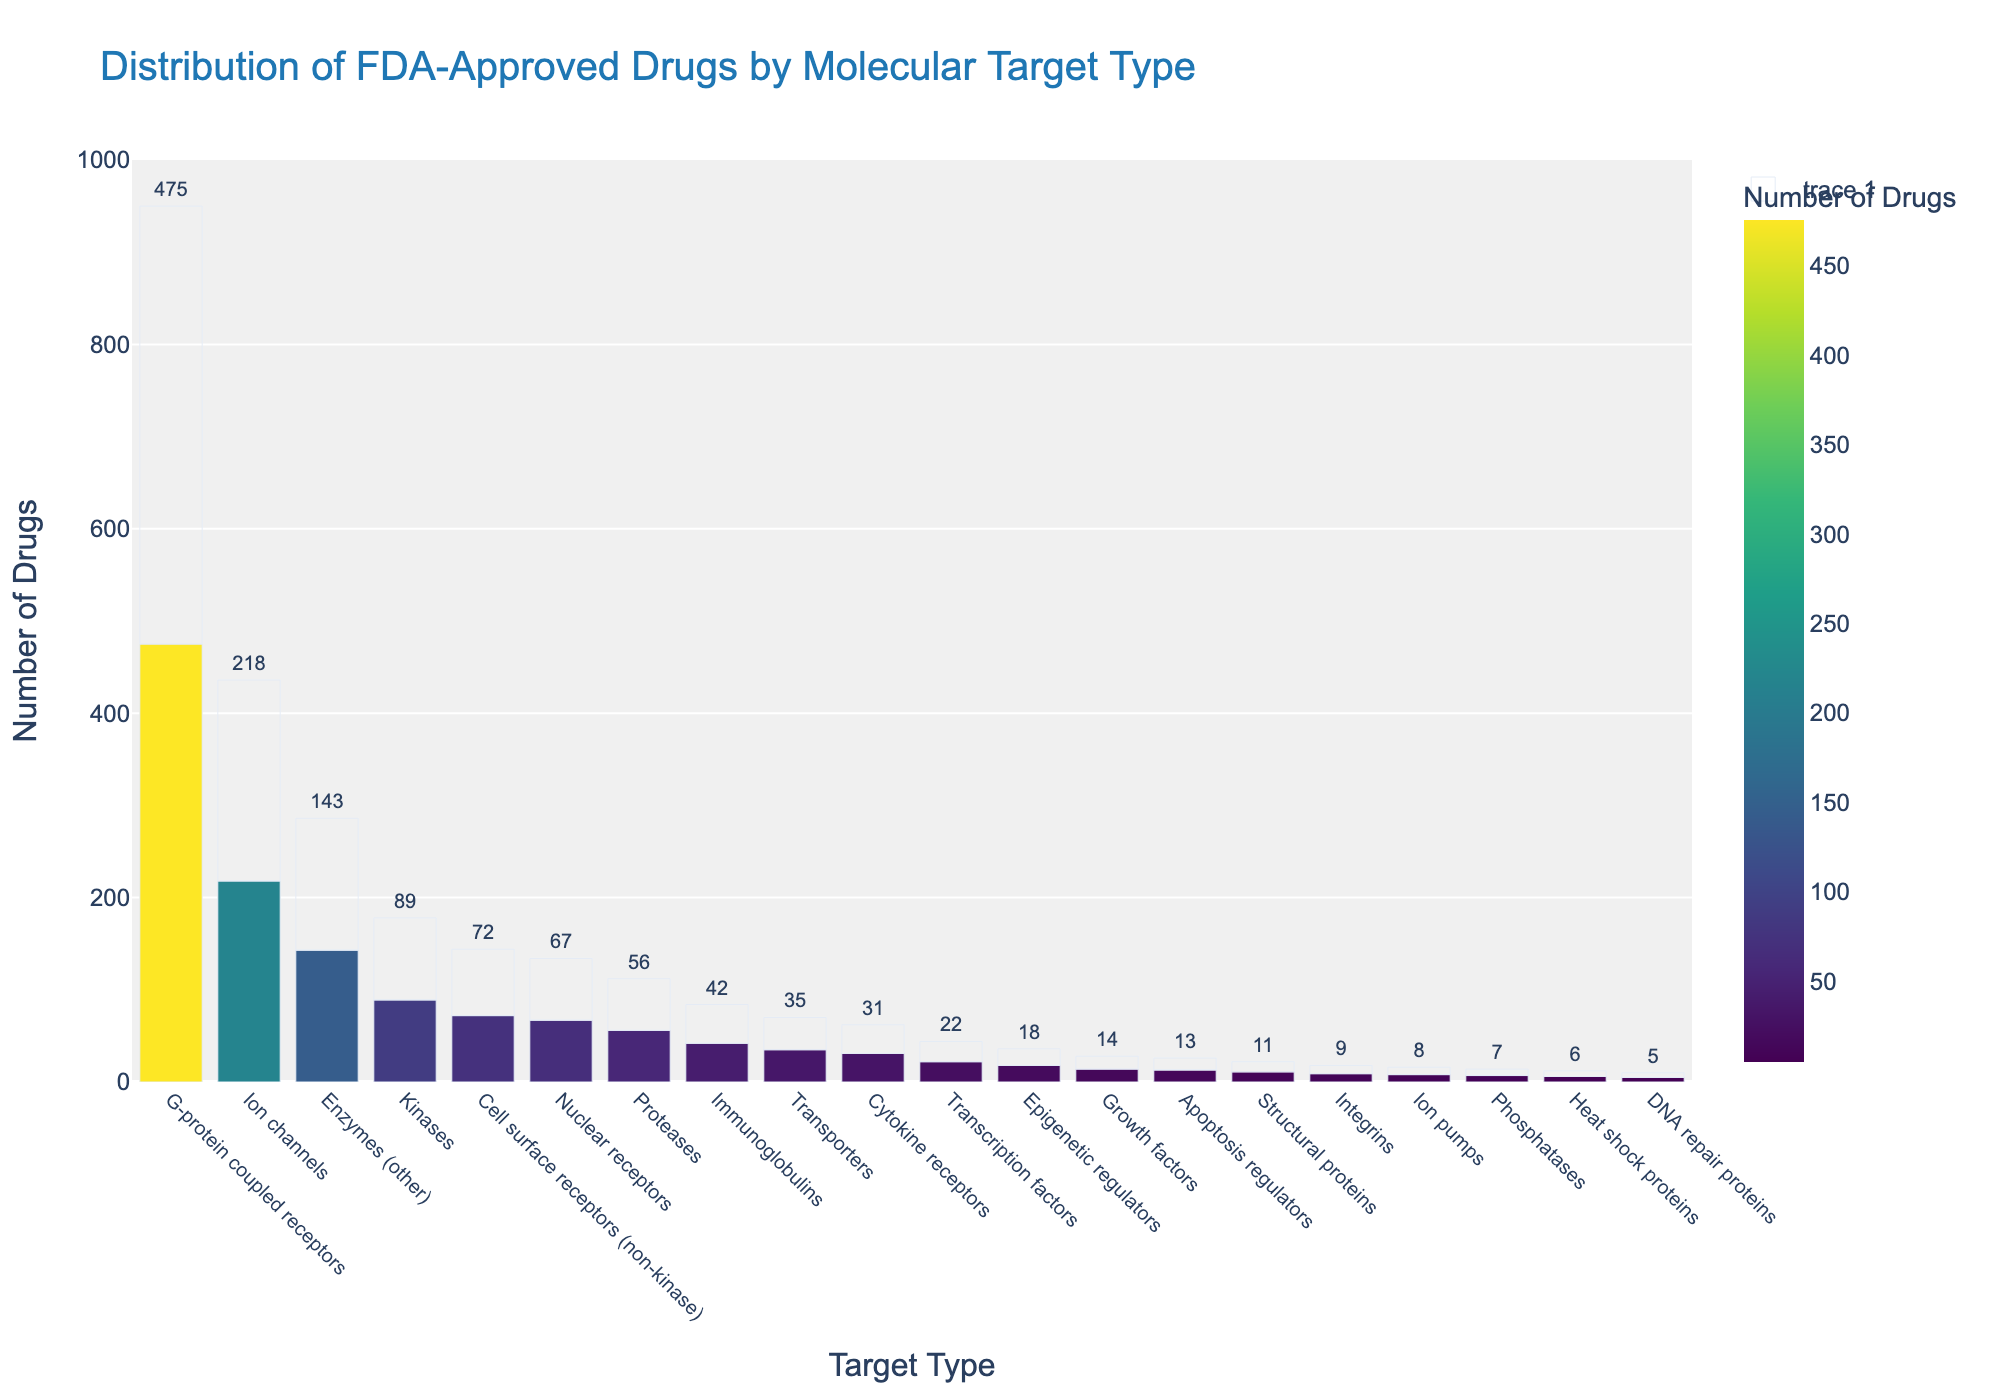Which target type has the highest number of FDA-approved drugs? The bar representing "G-protein coupled receptors" is the tallest, indicating it has the highest number of FDA-approved drugs.
Answer: G-protein coupled receptors Which target type has the fewest number of FDA-approved drugs? The bar representing "DNA repair proteins" is the shortest, indicating it has the fewest number of FDA-approved drugs.
Answer: DNA repair proteins How many more FDA-approved drugs target G-protein coupled receptors compared to ion channels? To find the difference, subtract the number of FDA-approved drugs targeting ion channels (218) from those targeting G-protein coupled receptors (475): 475 - 218.
Answer: 257 What is the sum of FDA-approved drugs for proteases and enzymes (other)? To get the total, add the FDA-approved drugs for proteases (56) and enzymes (other) (143): 56 + 143.
Answer: 199 Which target type has a similar number of FDA-approved drugs to nuclear receptors? Look for the bar whose height is close to the bar for nuclear receptors (67). The bar for cell surface receptors (non-kinase) with 72 drugs is the closest.
Answer: Cell surface receptors (non-kinase) Which target type has fewer than 10 FDA-approved drugs? Identify the bars with heights lower than 10: integrins (9), phosphatases (7), DNA repair proteins (5), and heat shock proteins (6).
Answer: Integrins, phosphatases, DNA repair proteins, heat shock proteins Are there more FDA-approved drugs targeting transcription factors or epigenetic regulators? Compare the heights of the bars for transcription factors (22) and epigenetic regulators (18). The bar for transcription factors is taller.
Answer: Transcription factors What is the average number of FDA-approved drugs across integrins, heat shock proteins, and structural proteins? Sum the numbers for integrins (9), heat shock proteins (6), and structural proteins (11) and divide by 3: (9 + 6 + 11) / 3.
Answer: 8.67 Which target type has just over 200 FDA-approved drugs? Identify the bar with a height slightly above 200: ion channels with 218 drugs.
Answer: Ion channels 